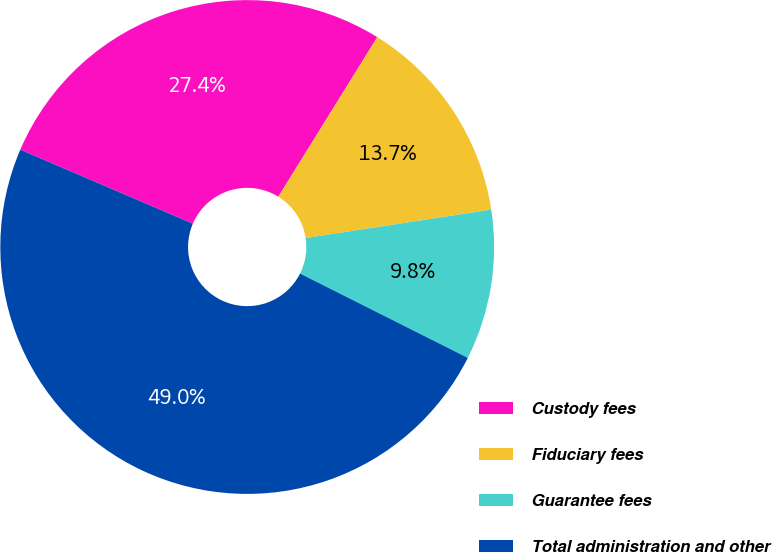Convert chart to OTSL. <chart><loc_0><loc_0><loc_500><loc_500><pie_chart><fcel>Custody fees<fcel>Fiduciary fees<fcel>Guarantee fees<fcel>Total administration and other<nl><fcel>27.39%<fcel>13.75%<fcel>9.83%<fcel>49.04%<nl></chart> 